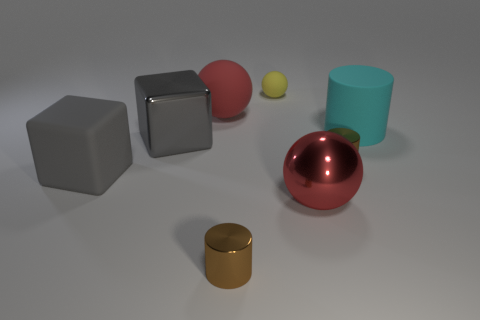Subtract all small yellow spheres. How many spheres are left? 2 Subtract all red spheres. How many spheres are left? 1 Subtract all cylinders. How many objects are left? 5 Add 2 large metallic cubes. How many objects exist? 10 Add 7 red shiny cylinders. How many red shiny cylinders exist? 7 Subtract 0 gray cylinders. How many objects are left? 8 Subtract 2 blocks. How many blocks are left? 0 Subtract all brown cubes. Subtract all blue cylinders. How many cubes are left? 2 Subtract all purple cylinders. How many yellow cubes are left? 0 Subtract all matte objects. Subtract all cubes. How many objects are left? 2 